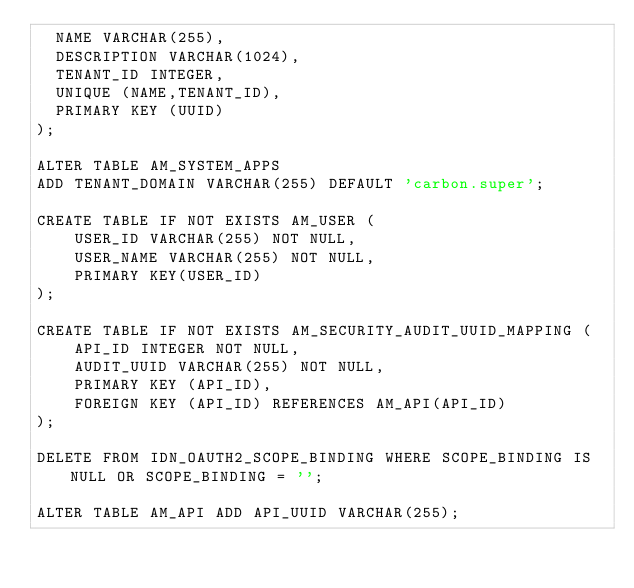Convert code to text. <code><loc_0><loc_0><loc_500><loc_500><_SQL_>  NAME VARCHAR(255),
  DESCRIPTION VARCHAR(1024),
  TENANT_ID INTEGER,
  UNIQUE (NAME,TENANT_ID),
  PRIMARY KEY (UUID)
);

ALTER TABLE AM_SYSTEM_APPS
ADD TENANT_DOMAIN VARCHAR(255) DEFAULT 'carbon.super';

CREATE TABLE IF NOT EXISTS AM_USER (
    USER_ID VARCHAR(255) NOT NULL,
    USER_NAME VARCHAR(255) NOT NULL,
    PRIMARY KEY(USER_ID)
);

CREATE TABLE IF NOT EXISTS AM_SECURITY_AUDIT_UUID_MAPPING (
    API_ID INTEGER NOT NULL,
    AUDIT_UUID VARCHAR(255) NOT NULL,
    PRIMARY KEY (API_ID),
    FOREIGN KEY (API_ID) REFERENCES AM_API(API_ID)
);

DELETE FROM IDN_OAUTH2_SCOPE_BINDING WHERE SCOPE_BINDING IS NULL OR SCOPE_BINDING = '';

ALTER TABLE AM_API ADD API_UUID VARCHAR(255);</code> 